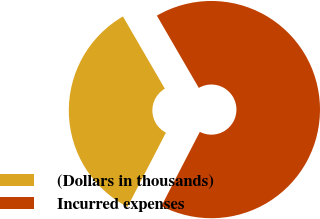Convert chart to OTSL. <chart><loc_0><loc_0><loc_500><loc_500><pie_chart><fcel>(Dollars in thousands)<fcel>Incurred expenses<nl><fcel>34.03%<fcel>65.97%<nl></chart> 